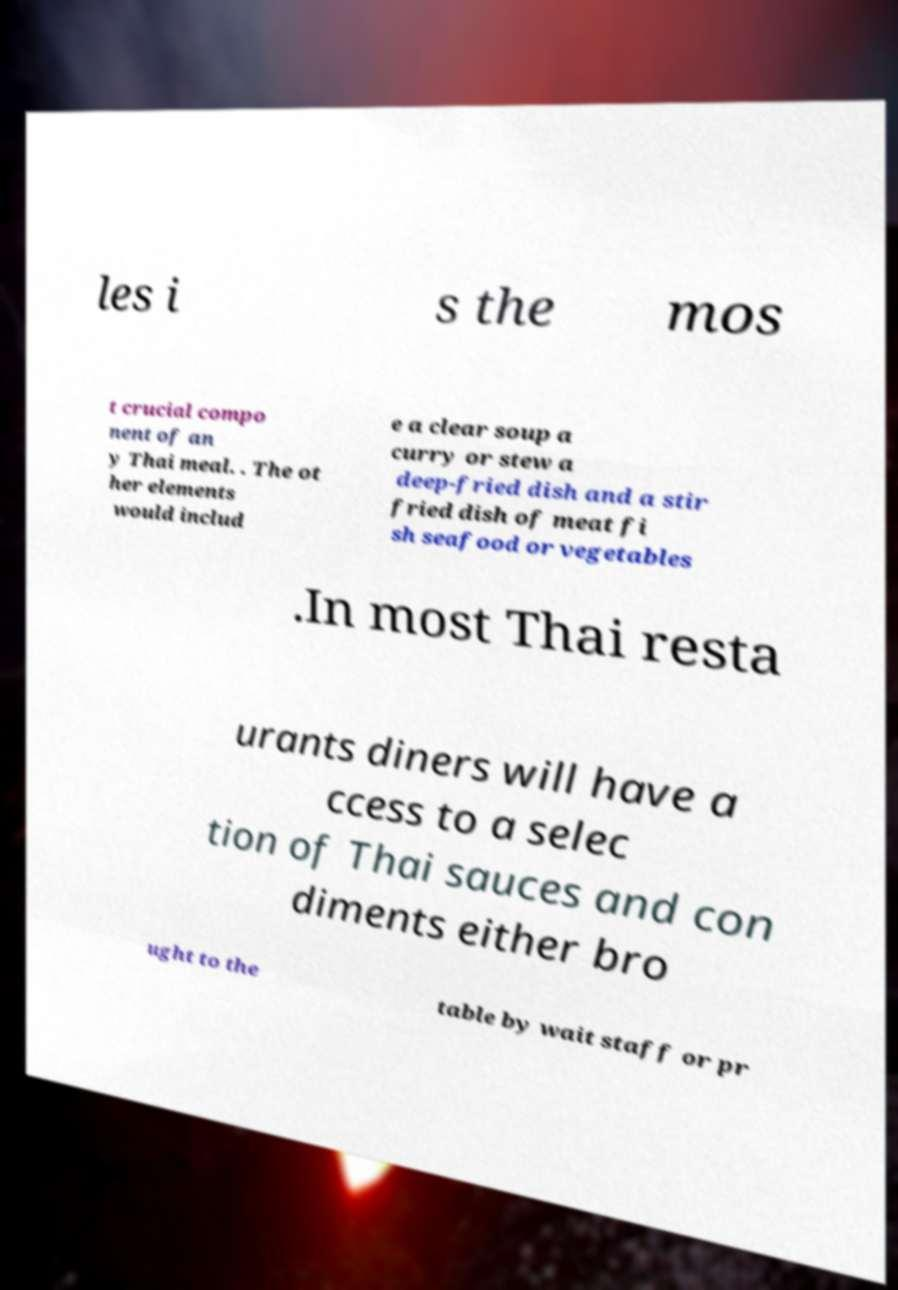What messages or text are displayed in this image? I need them in a readable, typed format. les i s the mos t crucial compo nent of an y Thai meal. . The ot her elements would includ e a clear soup a curry or stew a deep-fried dish and a stir fried dish of meat fi sh seafood or vegetables .In most Thai resta urants diners will have a ccess to a selec tion of Thai sauces and con diments either bro ught to the table by wait staff or pr 